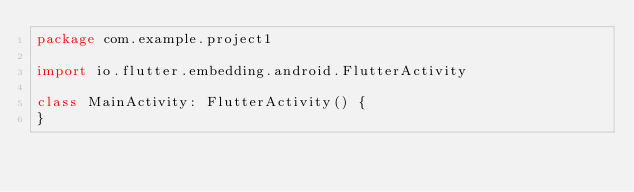Convert code to text. <code><loc_0><loc_0><loc_500><loc_500><_Kotlin_>package com.example.project1

import io.flutter.embedding.android.FlutterActivity

class MainActivity: FlutterActivity() {
}
</code> 